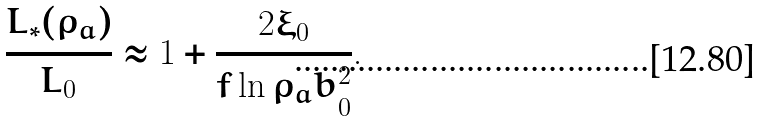<formula> <loc_0><loc_0><loc_500><loc_500>\frac { L _ { * } ( \rho _ { a } ) } { L _ { 0 } } \approx 1 + \frac { 2 \xi _ { 0 } } { f \ln \rho _ { a } b _ { 0 } ^ { 2 } } .</formula> 